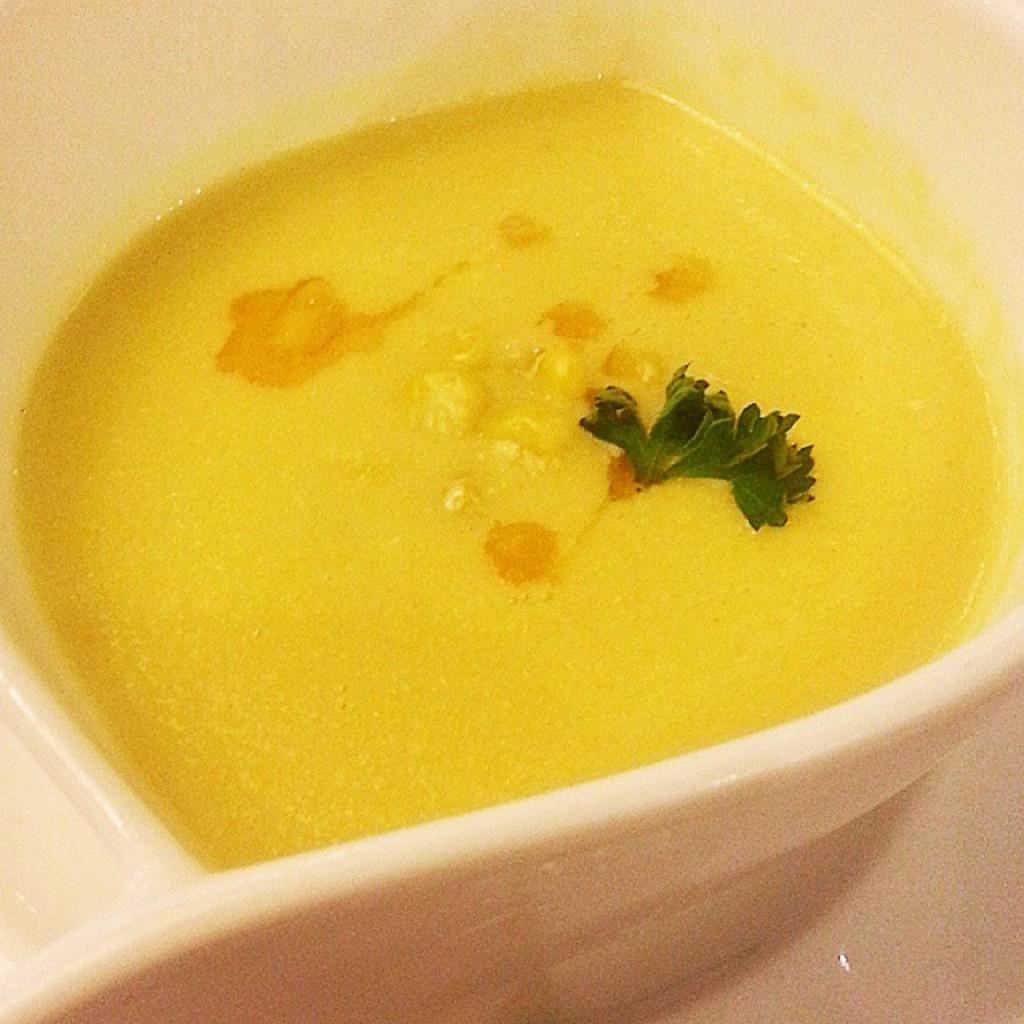Please provide a concise description of this image. In this image in front there is a food item in a plate which was placed on the table. 